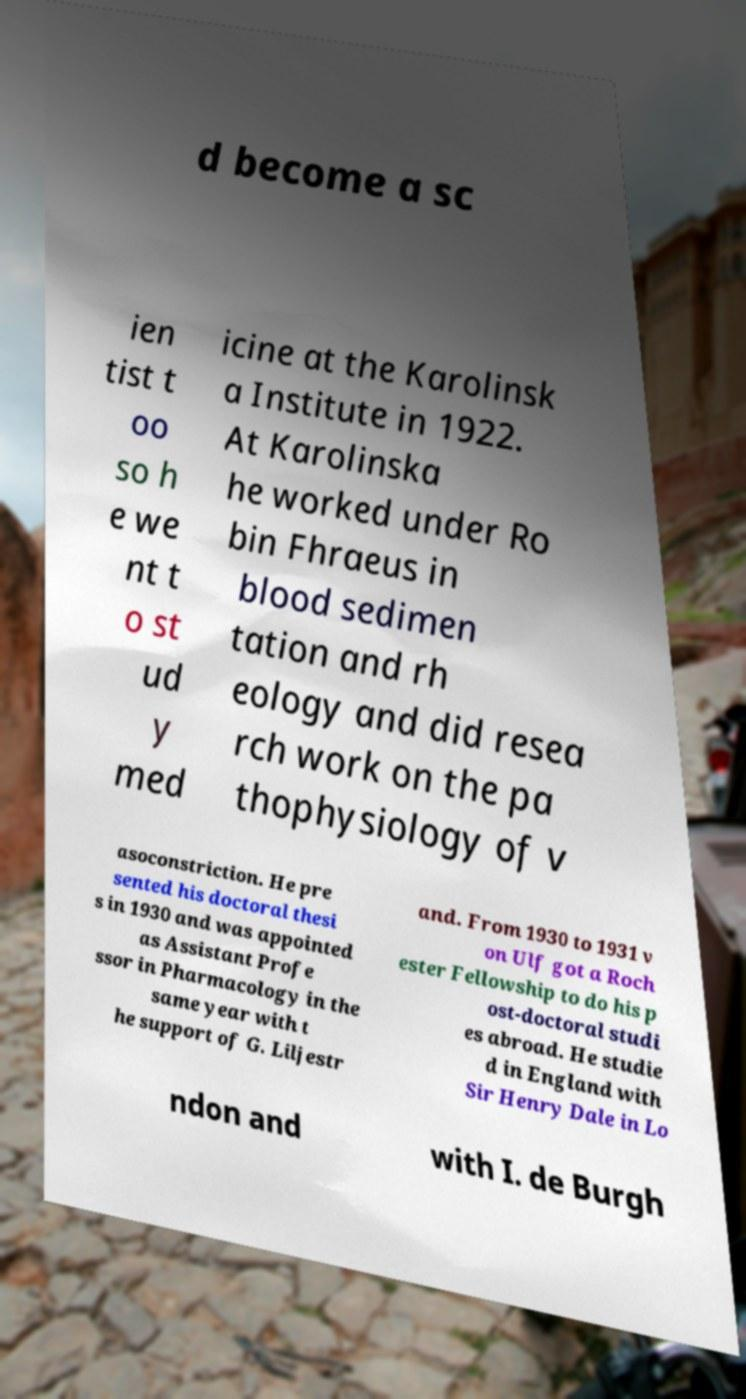Could you extract and type out the text from this image? d become a sc ien tist t oo so h e we nt t o st ud y med icine at the Karolinsk a Institute in 1922. At Karolinska he worked under Ro bin Fhraeus in blood sedimen tation and rh eology and did resea rch work on the pa thophysiology of v asoconstriction. He pre sented his doctoral thesi s in 1930 and was appointed as Assistant Profe ssor in Pharmacology in the same year with t he support of G. Liljestr and. From 1930 to 1931 v on Ulf got a Roch ester Fellowship to do his p ost-doctoral studi es abroad. He studie d in England with Sir Henry Dale in Lo ndon and with I. de Burgh 